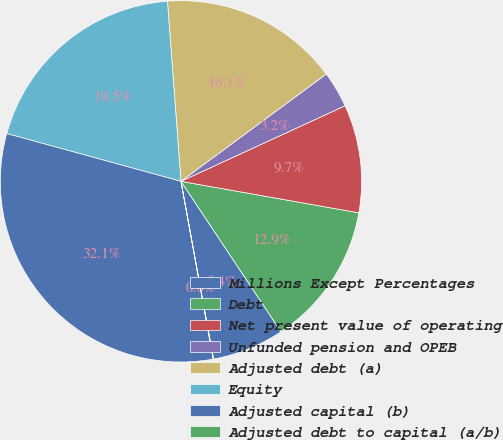<chart> <loc_0><loc_0><loc_500><loc_500><pie_chart><fcel>Millions Except Percentages<fcel>Debt<fcel>Net present value of operating<fcel>Unfunded pension and OPEB<fcel>Adjusted debt (a)<fcel>Equity<fcel>Adjusted capital (b)<fcel>Adjusted debt to capital (a/b)<nl><fcel>6.45%<fcel>12.87%<fcel>9.66%<fcel>3.25%<fcel>16.07%<fcel>19.55%<fcel>32.11%<fcel>0.04%<nl></chart> 